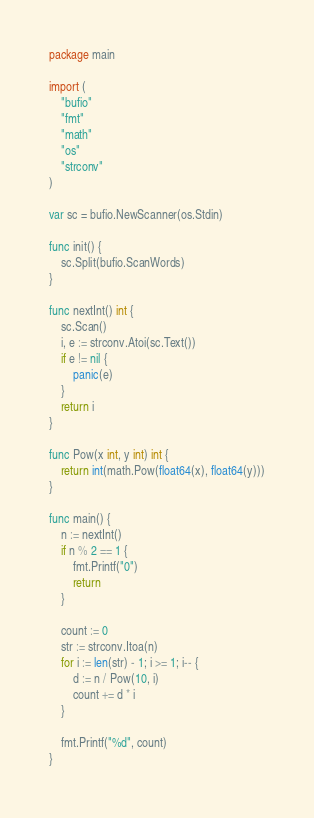<code> <loc_0><loc_0><loc_500><loc_500><_Go_>package main

import (
	"bufio"
	"fmt"
	"math"
	"os"
	"strconv"
)

var sc = bufio.NewScanner(os.Stdin)

func init() {
	sc.Split(bufio.ScanWords)
}

func nextInt() int {
	sc.Scan()
	i, e := strconv.Atoi(sc.Text())
	if e != nil {
		panic(e)
	}
	return i
}

func Pow(x int, y int) int {
	return int(math.Pow(float64(x), float64(y)))
}

func main() {
	n := nextInt()
	if n % 2 == 1 {
		fmt.Printf("0")
		return
	}

	count := 0
	str := strconv.Itoa(n)
	for i := len(str) - 1; i >= 1; i-- {
		d := n / Pow(10, i)
		count += d * i
	}

	fmt.Printf("%d", count)
}
</code> 